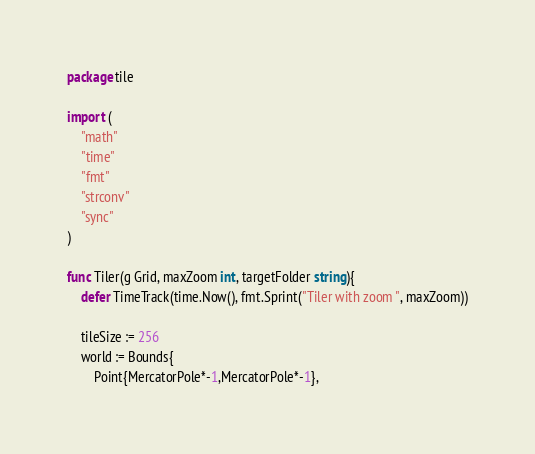<code> <loc_0><loc_0><loc_500><loc_500><_Go_>package tile

import (
	"math"
	"time"
	"fmt"
	"strconv"
	"sync"
)

func Tiler(g Grid, maxZoom int, targetFolder string){
	defer TimeTrack(time.Now(), fmt.Sprint("Tiler with zoom ", maxZoom))

	tileSize := 256
	world := Bounds{
		Point{MercatorPole*-1,MercatorPole*-1},</code> 